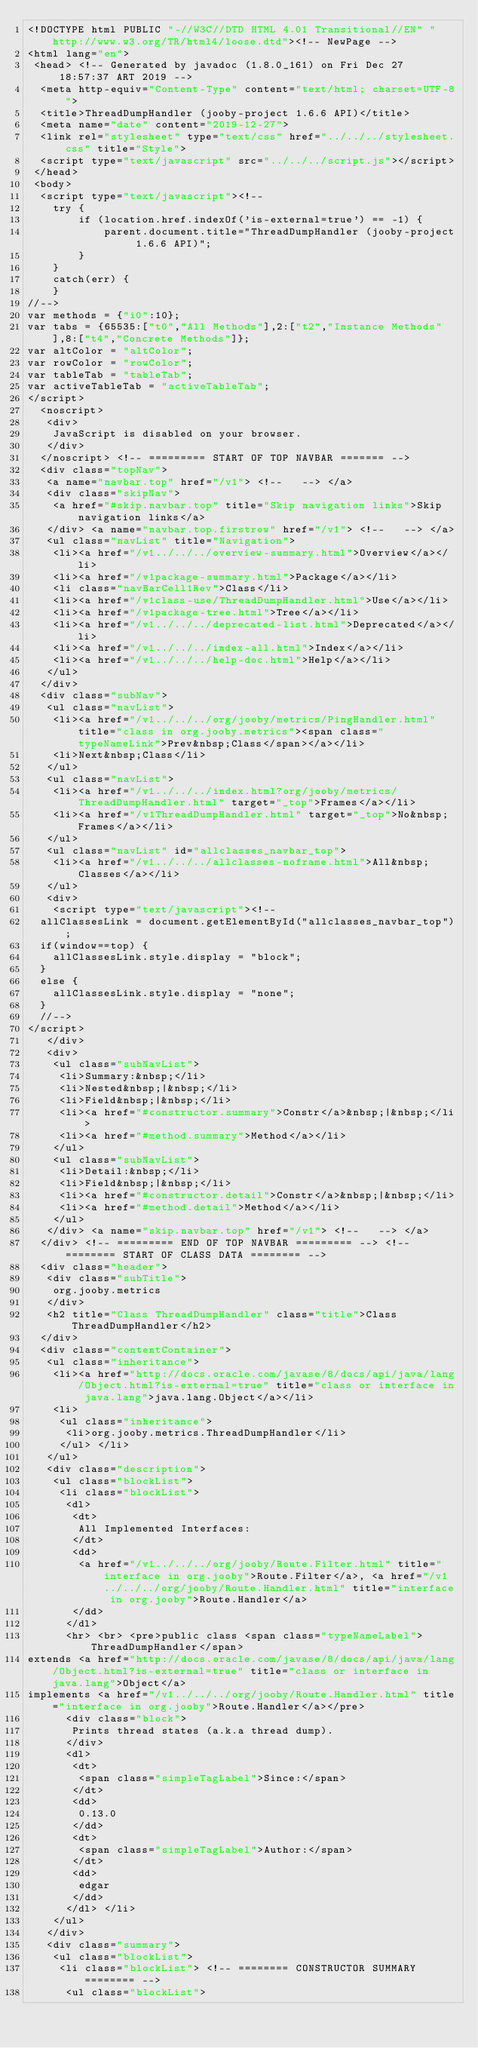Convert code to text. <code><loc_0><loc_0><loc_500><loc_500><_HTML_><!DOCTYPE html PUBLIC "-//W3C//DTD HTML 4.01 Transitional//EN" "http://www.w3.org/TR/html4/loose.dtd"><!-- NewPage -->
<html lang="en"> 
 <head> <!-- Generated by javadoc (1.8.0_161) on Fri Dec 27 18:57:37 ART 2019 --> 
  <meta http-equiv="Content-Type" content="text/html; charset=UTF-8"> 
  <title>ThreadDumpHandler (jooby-project 1.6.6 API)</title> 
  <meta name="date" content="2019-12-27"> 
  <link rel="stylesheet" type="text/css" href="../../../stylesheet.css" title="Style"> 
  <script type="text/javascript" src="../../../script.js"></script> 
 </head> 
 <body> 
  <script type="text/javascript"><!--
    try {
        if (location.href.indexOf('is-external=true') == -1) {
            parent.document.title="ThreadDumpHandler (jooby-project 1.6.6 API)";
        }
    }
    catch(err) {
    }
//-->
var methods = {"i0":10};
var tabs = {65535:["t0","All Methods"],2:["t2","Instance Methods"],8:["t4","Concrete Methods"]};
var altColor = "altColor";
var rowColor = "rowColor";
var tableTab = "tableTab";
var activeTableTab = "activeTableTab";
</script> 
  <noscript> 
   <div>
    JavaScript is disabled on your browser.
   </div> 
  </noscript> <!-- ========= START OF TOP NAVBAR ======= --> 
  <div class="topNav">
   <a name="navbar.top" href="/v1"> <!--   --> </a> 
   <div class="skipNav">
    <a href="#skip.navbar.top" title="Skip navigation links">Skip navigation links</a>
   </div> <a name="navbar.top.firstrow" href="/v1"> <!--   --> </a> 
   <ul class="navList" title="Navigation"> 
    <li><a href="/v1../../../overview-summary.html">Overview</a></li> 
    <li><a href="/v1package-summary.html">Package</a></li> 
    <li class="navBarCell1Rev">Class</li> 
    <li><a href="/v1class-use/ThreadDumpHandler.html">Use</a></li> 
    <li><a href="/v1package-tree.html">Tree</a></li> 
    <li><a href="/v1../../../deprecated-list.html">Deprecated</a></li> 
    <li><a href="/v1../../../index-all.html">Index</a></li> 
    <li><a href="/v1../../../help-doc.html">Help</a></li> 
   </ul> 
  </div> 
  <div class="subNav"> 
   <ul class="navList"> 
    <li><a href="/v1../../../org/jooby/metrics/PingHandler.html" title="class in org.jooby.metrics"><span class="typeNameLink">Prev&nbsp;Class</span></a></li> 
    <li>Next&nbsp;Class</li> 
   </ul> 
   <ul class="navList"> 
    <li><a href="/v1../../../index.html?org/jooby/metrics/ThreadDumpHandler.html" target="_top">Frames</a></li> 
    <li><a href="/v1ThreadDumpHandler.html" target="_top">No&nbsp;Frames</a></li> 
   </ul> 
   <ul class="navList" id="allclasses_navbar_top"> 
    <li><a href="/v1../../../allclasses-noframe.html">All&nbsp;Classes</a></li> 
   </ul> 
   <div> 
    <script type="text/javascript"><!--
  allClassesLink = document.getElementById("allclasses_navbar_top");
  if(window==top) {
    allClassesLink.style.display = "block";
  }
  else {
    allClassesLink.style.display = "none";
  }
  //-->
</script> 
   </div> 
   <div> 
    <ul class="subNavList"> 
     <li>Summary:&nbsp;</li> 
     <li>Nested&nbsp;|&nbsp;</li> 
     <li>Field&nbsp;|&nbsp;</li> 
     <li><a href="#constructor.summary">Constr</a>&nbsp;|&nbsp;</li> 
     <li><a href="#method.summary">Method</a></li> 
    </ul> 
    <ul class="subNavList"> 
     <li>Detail:&nbsp;</li> 
     <li>Field&nbsp;|&nbsp;</li> 
     <li><a href="#constructor.detail">Constr</a>&nbsp;|&nbsp;</li> 
     <li><a href="#method.detail">Method</a></li> 
    </ul> 
   </div> <a name="skip.navbar.top" href="/v1"> <!--   --> </a>
  </div> <!-- ========= END OF TOP NAVBAR ========= --> <!-- ======== START OF CLASS DATA ======== --> 
  <div class="header"> 
   <div class="subTitle">
    org.jooby.metrics
   </div> 
   <h2 title="Class ThreadDumpHandler" class="title">Class ThreadDumpHandler</h2> 
  </div> 
  <div class="contentContainer"> 
   <ul class="inheritance"> 
    <li><a href="http://docs.oracle.com/javase/8/docs/api/java/lang/Object.html?is-external=true" title="class or interface in java.lang">java.lang.Object</a></li> 
    <li> 
     <ul class="inheritance"> 
      <li>org.jooby.metrics.ThreadDumpHandler</li> 
     </ul> </li> 
   </ul> 
   <div class="description"> 
    <ul class="blockList"> 
     <li class="blockList"> 
      <dl> 
       <dt>
        All Implemented Interfaces:
       </dt> 
       <dd>
        <a href="/v1../../../org/jooby/Route.Filter.html" title="interface in org.jooby">Route.Filter</a>, <a href="/v1../../../org/jooby/Route.Handler.html" title="interface in org.jooby">Route.Handler</a>
       </dd> 
      </dl> 
      <hr> <br> <pre>public class <span class="typeNameLabel">ThreadDumpHandler</span>
extends <a href="http://docs.oracle.com/javase/8/docs/api/java/lang/Object.html?is-external=true" title="class or interface in java.lang">Object</a>
implements <a href="/v1../../../org/jooby/Route.Handler.html" title="interface in org.jooby">Route.Handler</a></pre> 
      <div class="block">
       Prints thread states (a.k.a thread dump).
      </div> 
      <dl> 
       <dt>
        <span class="simpleTagLabel">Since:</span>
       </dt> 
       <dd>
        0.13.0
       </dd> 
       <dt>
        <span class="simpleTagLabel">Author:</span>
       </dt> 
       <dd>
        edgar
       </dd> 
      </dl> </li> 
    </ul> 
   </div> 
   <div class="summary"> 
    <ul class="blockList"> 
     <li class="blockList"> <!-- ======== CONSTRUCTOR SUMMARY ======== --> 
      <ul class="blockList"> </code> 